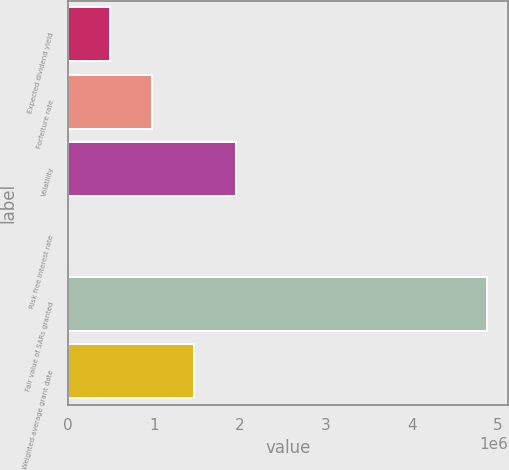<chart> <loc_0><loc_0><loc_500><loc_500><bar_chart><fcel>Expected dividend yield<fcel>Forfeiture rate<fcel>Volatility<fcel>Risk free interest rate<fcel>Fair value of SARs granted<fcel>Weighted-average grant date<nl><fcel>488402<fcel>976801<fcel>1.9536e+06<fcel>1.73<fcel>4.884e+06<fcel>1.4652e+06<nl></chart> 